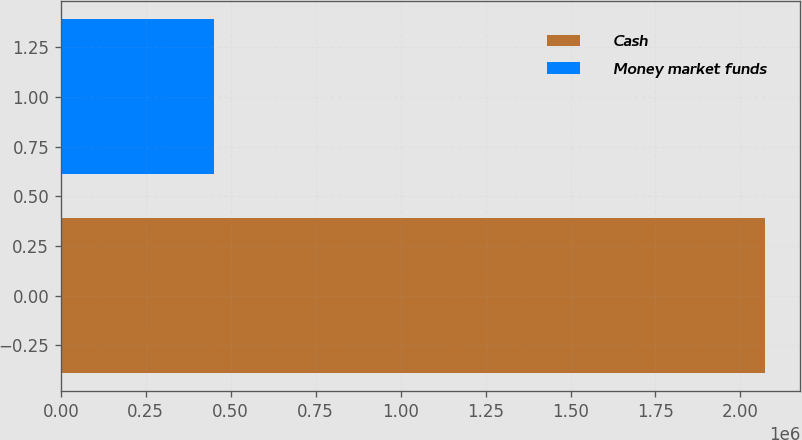Convert chart to OTSL. <chart><loc_0><loc_0><loc_500><loc_500><bar_chart><fcel>Cash<fcel>Money market funds<nl><fcel>2.0723e+06<fcel>449734<nl></chart> 